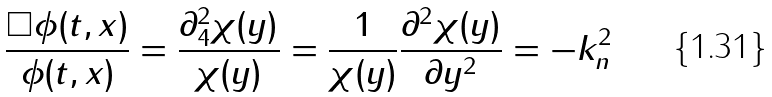<formula> <loc_0><loc_0><loc_500><loc_500>\frac { \Box \phi ( t , x ) } { \phi ( t , x ) } = \frac { \partial _ { 4 } ^ { 2 } \chi ( y ) } { \chi ( y ) } = \frac { 1 } { \chi ( y ) } \frac { \partial ^ { 2 } \chi ( y ) } { \partial y ^ { 2 } } = - k _ { n } ^ { 2 }</formula> 